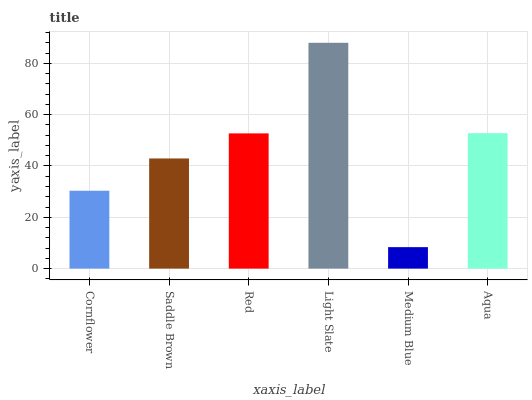Is Saddle Brown the minimum?
Answer yes or no. No. Is Saddle Brown the maximum?
Answer yes or no. No. Is Saddle Brown greater than Cornflower?
Answer yes or no. Yes. Is Cornflower less than Saddle Brown?
Answer yes or no. Yes. Is Cornflower greater than Saddle Brown?
Answer yes or no. No. Is Saddle Brown less than Cornflower?
Answer yes or no. No. Is Red the high median?
Answer yes or no. Yes. Is Saddle Brown the low median?
Answer yes or no. Yes. Is Aqua the high median?
Answer yes or no. No. Is Red the low median?
Answer yes or no. No. 